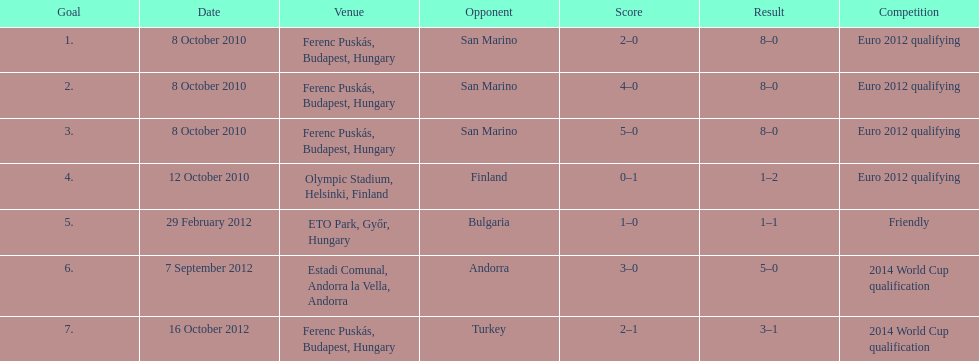Szalai scored only one more international goal against all other countries put together than he did against what one country? San Marino. 